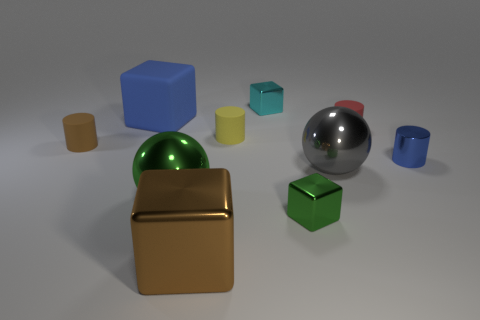If this arrangement were part of an art exhibition, what theme could it represent? This arrangement could represent the theme of 'Diversity in Unity' with different shapes, sizes, and colors sitting together harmoniously, symbolizing varied elements in a cohesive system. 